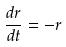Convert formula to latex. <formula><loc_0><loc_0><loc_500><loc_500>\frac { d r } { d t } = - r</formula> 